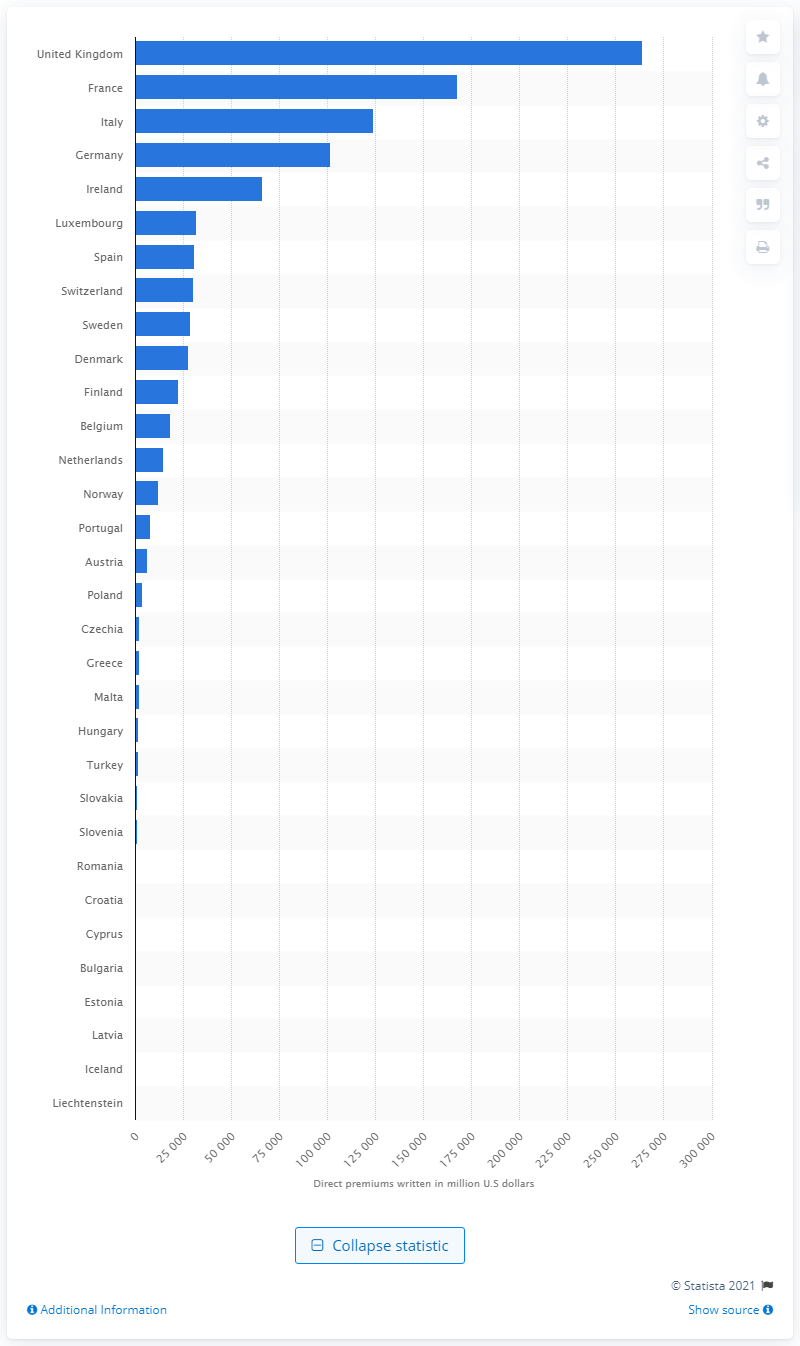Highlight a few significant elements in this photo. In 2019, France had the highest value of direct premiums written at almost 167.6 billion U.S dollars, making it the country with the highest amount of premiums written for insurance products. In the United Kingdom in 2019, a total of 264,221 units of direct premiums were written for life insurance, indicating the amount of money paid by policyholders to insurance companies for life insurance coverage. 